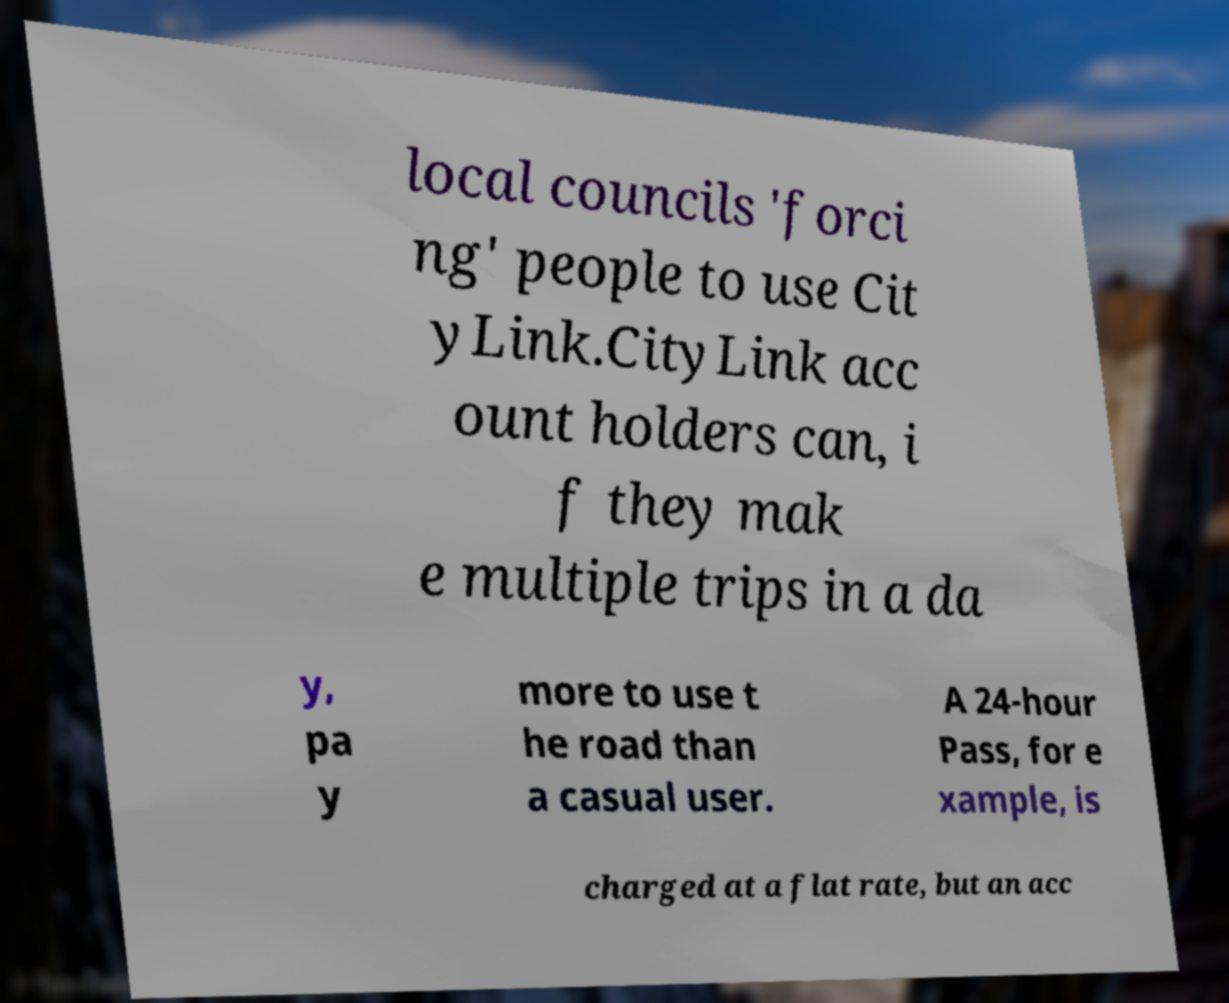Could you assist in decoding the text presented in this image and type it out clearly? local councils 'forci ng' people to use Cit yLink.CityLink acc ount holders can, i f they mak e multiple trips in a da y, pa y more to use t he road than a casual user. A 24-hour Pass, for e xample, is charged at a flat rate, but an acc 